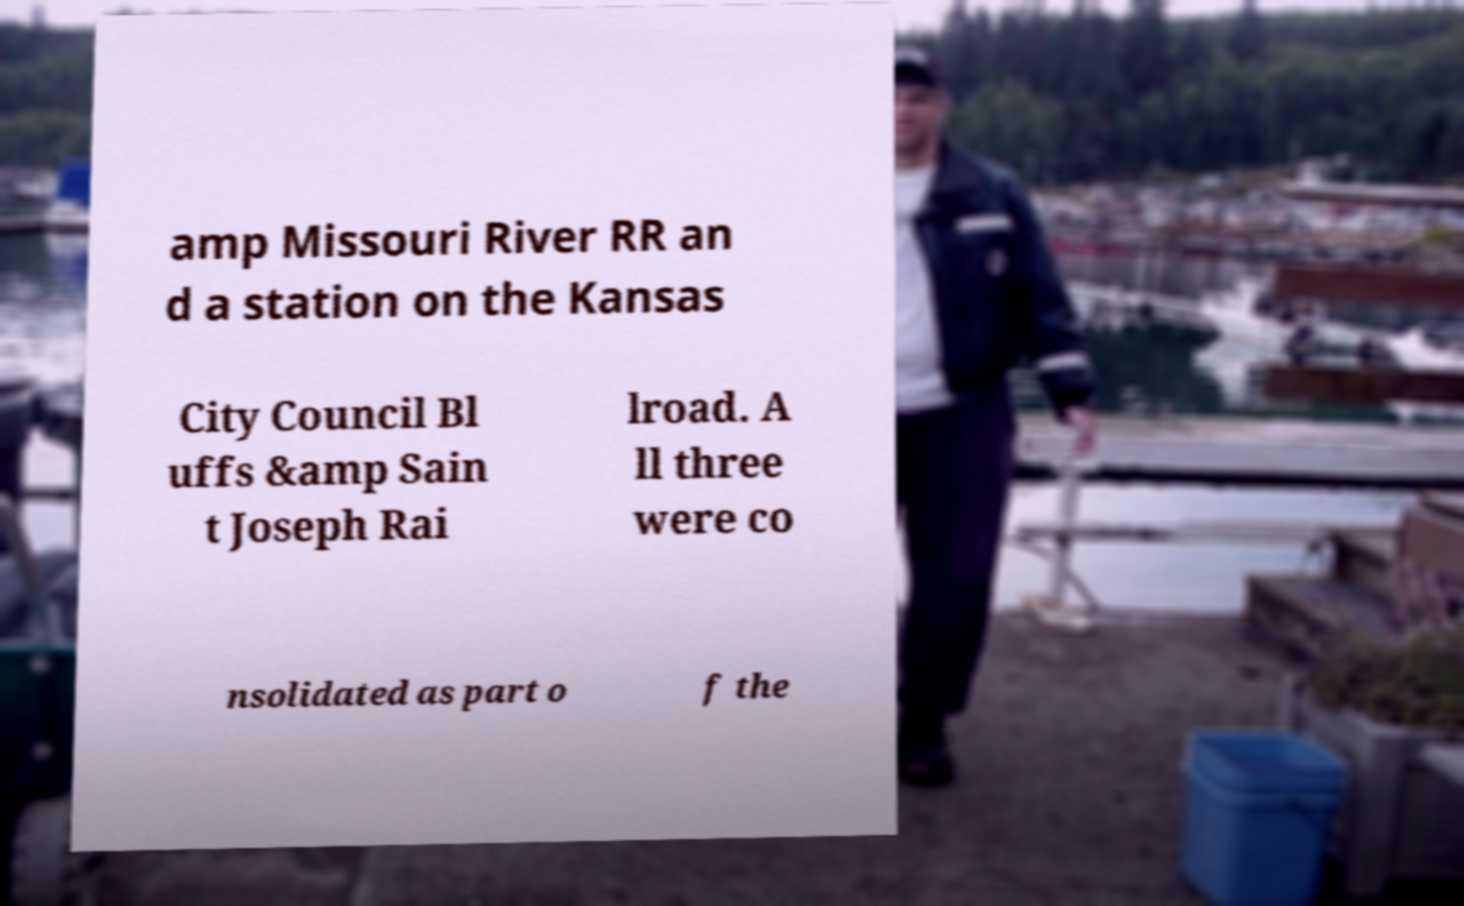What messages or text are displayed in this image? I need them in a readable, typed format. amp Missouri River RR an d a station on the Kansas City Council Bl uffs &amp Sain t Joseph Rai lroad. A ll three were co nsolidated as part o f the 